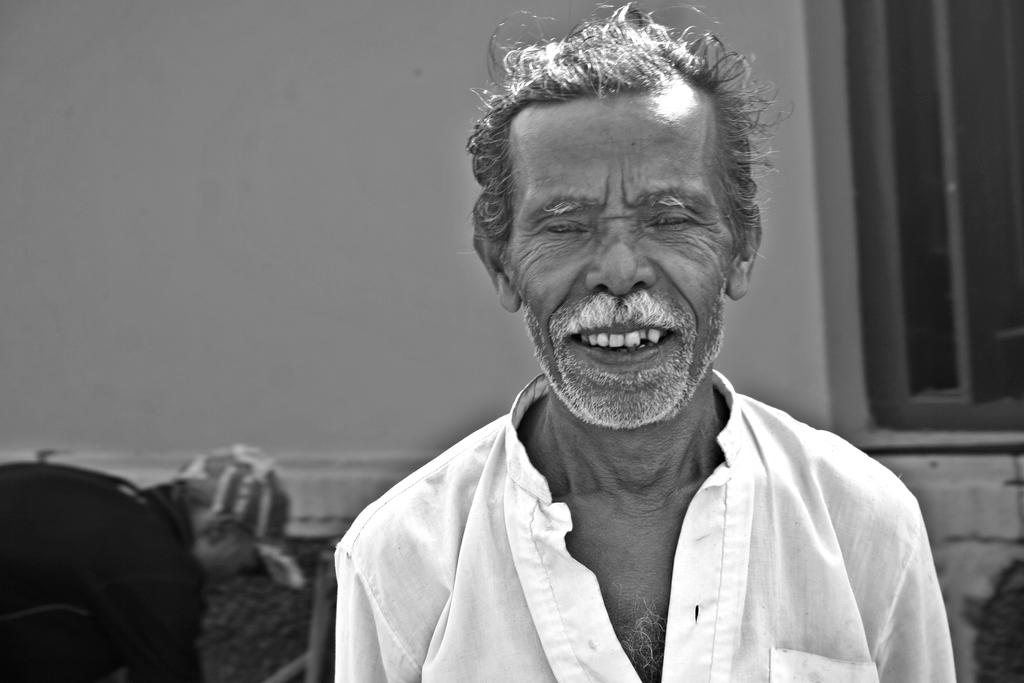What is the man in the image wearing? The man is wearing a white dress in the image. What can be seen in the background of the image? There is a window and a wall in the background of the image. Can you describe the other person in the image? There is another man wearing a cap on the left side of the image. What type of bread is being used as a tablecloth in the image? There is no bread present in the image, and it does not depict a tablecloth. 